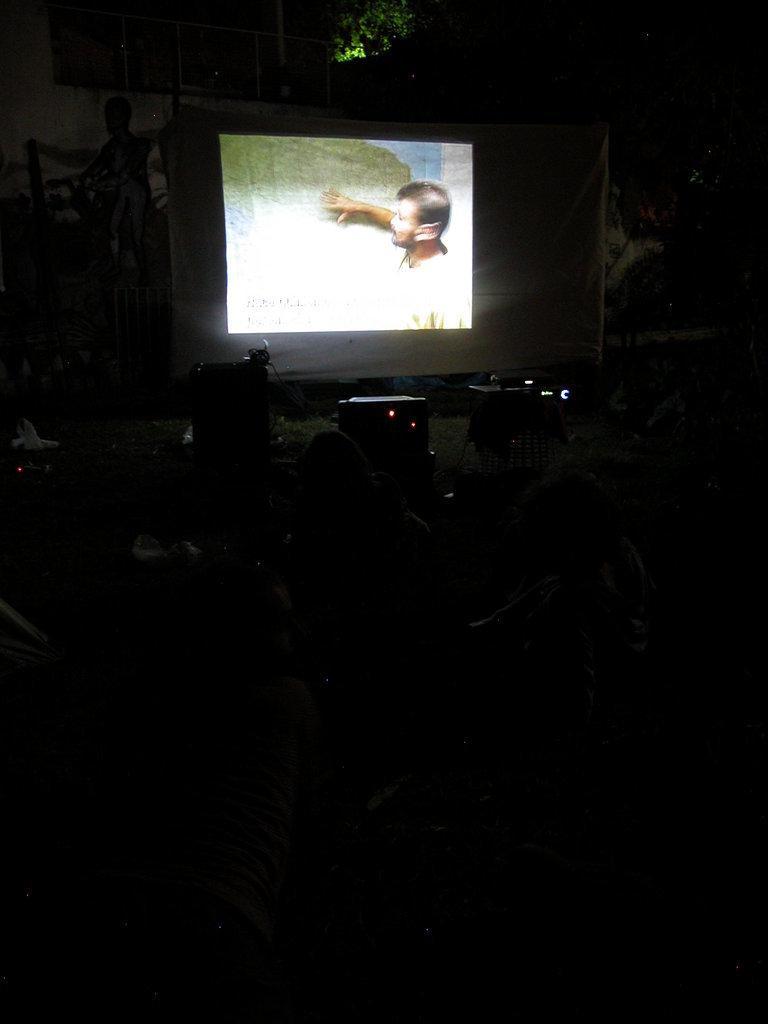Please provide a concise description of this image. In this image I can see a dark picture in which I can see few persons, a projector, few other objects and a projection screen on which I can see a projection of a person. In the background I can see few trees. 